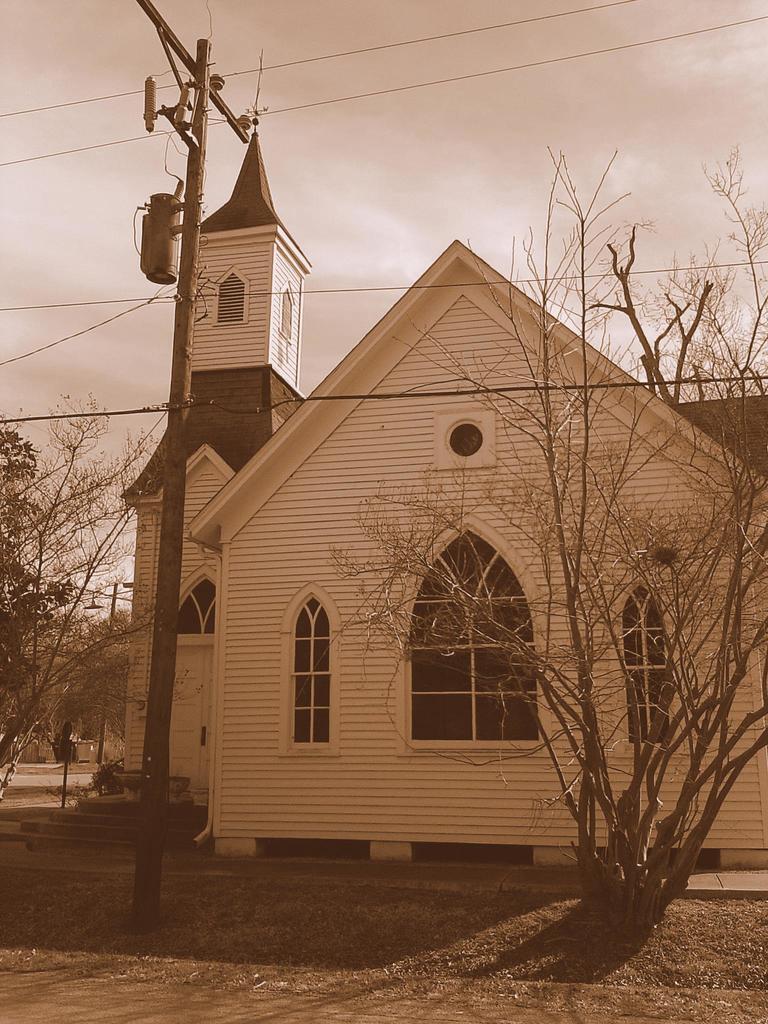Could you give a brief overview of what you see in this image? In the center of the image we can see a building, windows. In the background of the image we can see the trees, poles, board, wires. At the bottom of the image we can see the ground and dry leaves. At the top of the image we can see the clouds in the sky. 